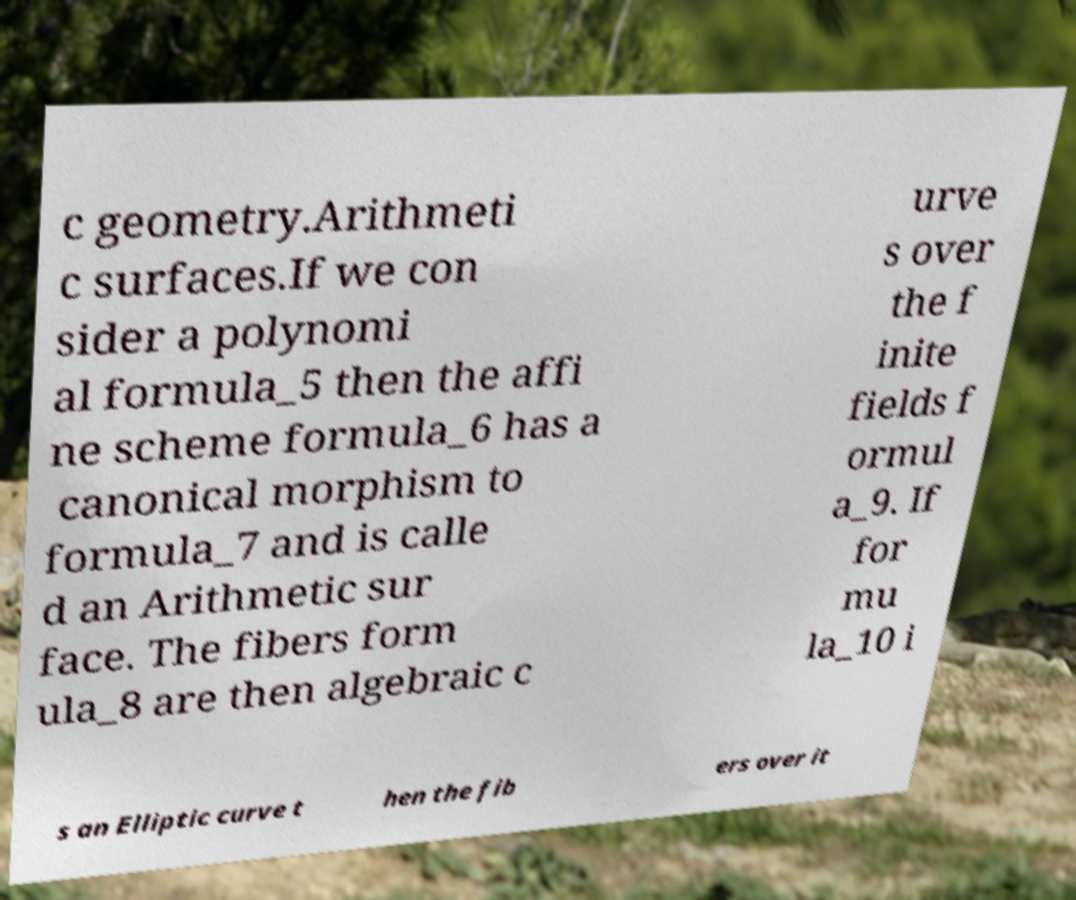Please identify and transcribe the text found in this image. c geometry.Arithmeti c surfaces.If we con sider a polynomi al formula_5 then the affi ne scheme formula_6 has a canonical morphism to formula_7 and is calle d an Arithmetic sur face. The fibers form ula_8 are then algebraic c urve s over the f inite fields f ormul a_9. If for mu la_10 i s an Elliptic curve t hen the fib ers over it 